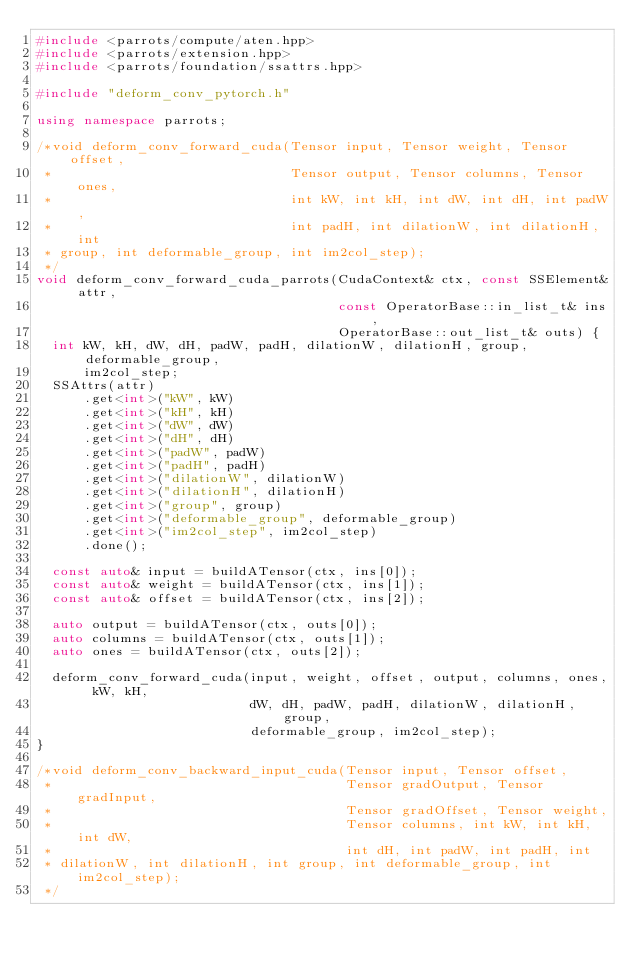Convert code to text. <code><loc_0><loc_0><loc_500><loc_500><_C++_>#include <parrots/compute/aten.hpp>
#include <parrots/extension.hpp>
#include <parrots/foundation/ssattrs.hpp>

#include "deform_conv_pytorch.h"

using namespace parrots;

/*void deform_conv_forward_cuda(Tensor input, Tensor weight, Tensor offset,
 *                              Tensor output, Tensor columns, Tensor ones,
 *                              int kW, int kH, int dW, int dH, int padW,
 *                              int padH, int dilationW, int dilationH, int
 * group, int deformable_group, int im2col_step);
 */
void deform_conv_forward_cuda_parrots(CudaContext& ctx, const SSElement& attr,
                                      const OperatorBase::in_list_t& ins,
                                      OperatorBase::out_list_t& outs) {
  int kW, kH, dW, dH, padW, padH, dilationW, dilationH, group, deformable_group,
      im2col_step;
  SSAttrs(attr)
      .get<int>("kW", kW)
      .get<int>("kH", kH)
      .get<int>("dW", dW)
      .get<int>("dH", dH)
      .get<int>("padW", padW)
      .get<int>("padH", padH)
      .get<int>("dilationW", dilationW)
      .get<int>("dilationH", dilationH)
      .get<int>("group", group)
      .get<int>("deformable_group", deformable_group)
      .get<int>("im2col_step", im2col_step)
      .done();

  const auto& input = buildATensor(ctx, ins[0]);
  const auto& weight = buildATensor(ctx, ins[1]);
  const auto& offset = buildATensor(ctx, ins[2]);

  auto output = buildATensor(ctx, outs[0]);
  auto columns = buildATensor(ctx, outs[1]);
  auto ones = buildATensor(ctx, outs[2]);

  deform_conv_forward_cuda(input, weight, offset, output, columns, ones, kW, kH,
                           dW, dH, padW, padH, dilationW, dilationH, group,
                           deformable_group, im2col_step);
}

/*void deform_conv_backward_input_cuda(Tensor input, Tensor offset,
 *                                     Tensor gradOutput, Tensor gradInput,
 *                                     Tensor gradOffset, Tensor weight,
 *                                     Tensor columns, int kW, int kH, int dW,
 *                                     int dH, int padW, int padH, int
 * dilationW, int dilationH, int group, int deformable_group, int im2col_step);
 */</code> 